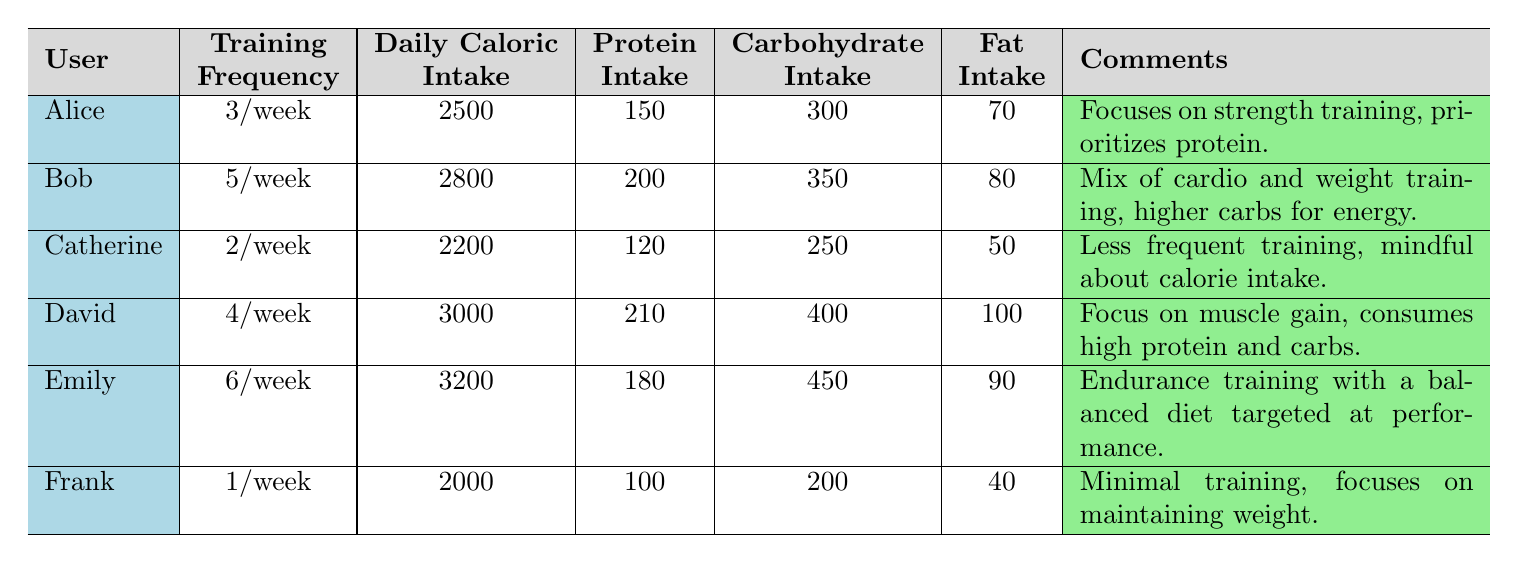What is the daily caloric intake for Emily? From the table, Emily's daily caloric intake is listed as 3200.
Answer: 3200 How often does Frank train per week? Frank's training frequency is listed as 1 time a week.
Answer: 1 time a week Which user has the highest protein intake? David has the highest protein intake at 210 grams, surpassing all other users listed.
Answer: David What is the sum of the carbohydrate intake for all users? To find the sum, add the carbohydrate intakes: 300 + 350 + 250 + 400 + 450 + 200 = 1950 grams.
Answer: 1950 Is Bob's training frequency higher than Catherine's? Yes, Bob trains 5 times a week while Catherine trains only 2 times a week, making Bob's frequency higher.
Answer: Yes What is the average daily caloric intake of all users? The average is calculated by summing their caloric intakes (2500 + 2800 + 2200 + 3000 + 3200 + 2000 = 15700) and dividing by 6 (15700 / 6 = 2616.67).
Answer: Approximately 2617 Who has the lowest fat intake and what is that amount? Frank has the lowest fat intake recorded at 40 grams.
Answer: 40 grams Is it true that Catherine has a higher protein intake than Frank? No, Catherine has a protein intake of 120 grams while Frank has 100 grams, so this statement is false.
Answer: No Which user has the least training frequency, and what is their daily caloric intake? Frank has the least training frequency at 1 time a week, with a daily caloric intake of 2000.
Answer: Frank, 2000 